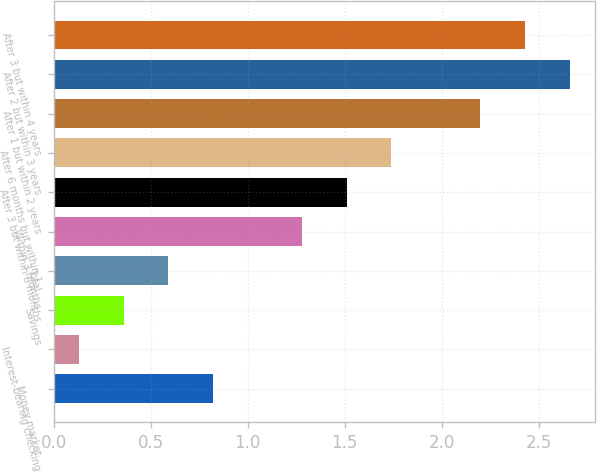Convert chart. <chart><loc_0><loc_0><loc_500><loc_500><bar_chart><fcel>Money market<fcel>Interest-bearing checking<fcel>Savings<fcel>Total<fcel>Within 3 months<fcel>After 3 but within 6 months<fcel>After 6 months but within 1<fcel>After 1 but within 2 years<fcel>After 2 but within 3 years<fcel>After 3 but within 4 years<nl><fcel>0.82<fcel>0.13<fcel>0.36<fcel>0.59<fcel>1.28<fcel>1.51<fcel>1.74<fcel>2.2<fcel>2.66<fcel>2.43<nl></chart> 